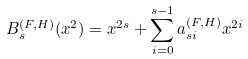Convert formula to latex. <formula><loc_0><loc_0><loc_500><loc_500>B ^ { ( F , H ) } _ { s } ( x ^ { 2 } ) = x ^ { 2 s } + \sum _ { i = 0 } ^ { s - 1 } a ^ { ( F , H ) } _ { s i } x ^ { 2 i }</formula> 